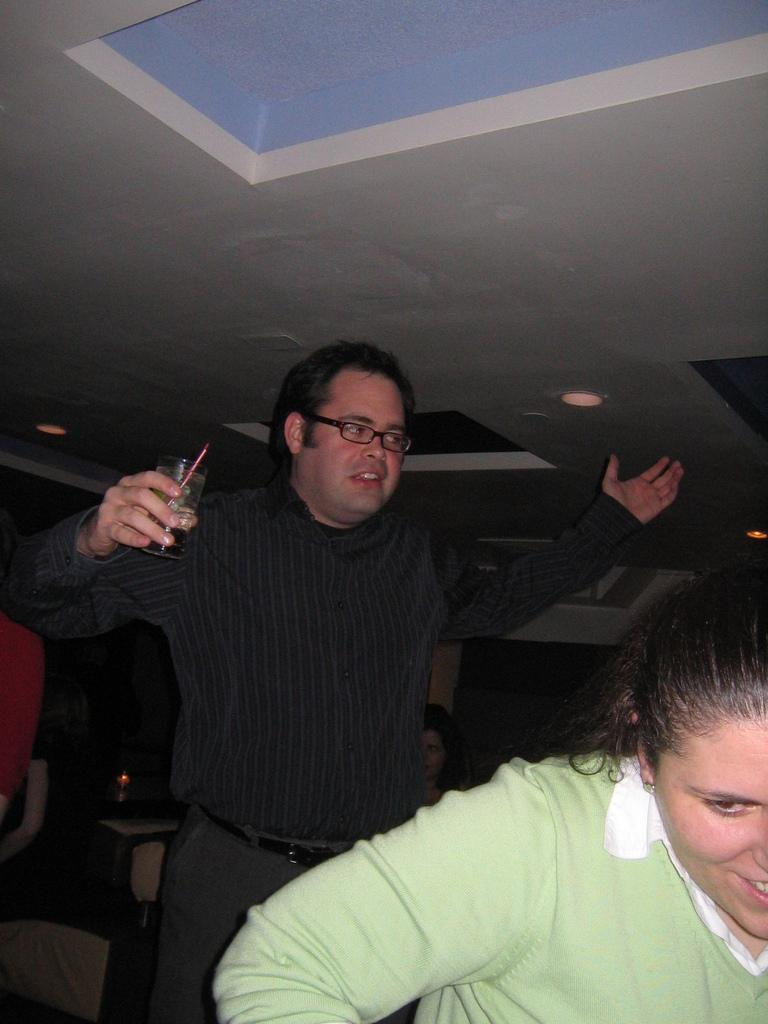Who are the people in the image? There is a woman and a man in the image. What is the man holding in his hand? The man is holding a beverage glass in his hand. What is the man's opinion on the current political situation in the image? There is no information about the man's opinion on the current political situation in the image. 